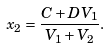Convert formula to latex. <formula><loc_0><loc_0><loc_500><loc_500>x _ { 2 } = \frac { C + D V _ { 1 } } { V _ { 1 } + V _ { 2 } } .</formula> 